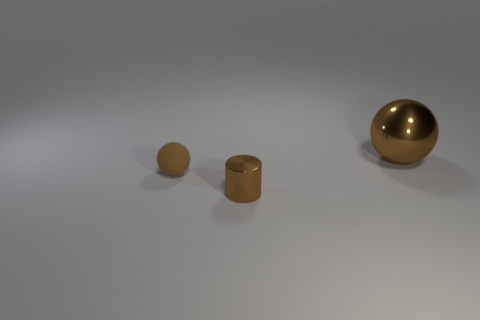Add 2 large balls. How many objects exist? 5 Subtract all spheres. How many objects are left? 1 Add 2 big metal cylinders. How many big metal cylinders exist? 2 Subtract 0 blue cylinders. How many objects are left? 3 Subtract all small matte things. Subtract all tiny metal objects. How many objects are left? 1 Add 3 brown metallic cylinders. How many brown metallic cylinders are left? 4 